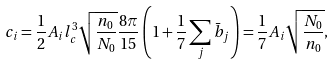<formula> <loc_0><loc_0><loc_500><loc_500>c _ { i } = \frac { 1 } { 2 } A _ { i } l _ { c } ^ { 3 } \sqrt { \frac { n _ { 0 } } { N _ { 0 } } } \frac { 8 \pi } { 1 5 } \left ( 1 + \frac { 1 } { 7 } \sum _ { j } \bar { b } _ { j } \right ) = \frac { 1 } { 7 } A _ { i } \sqrt { \frac { N _ { 0 } } { n _ { 0 } } } ,</formula> 